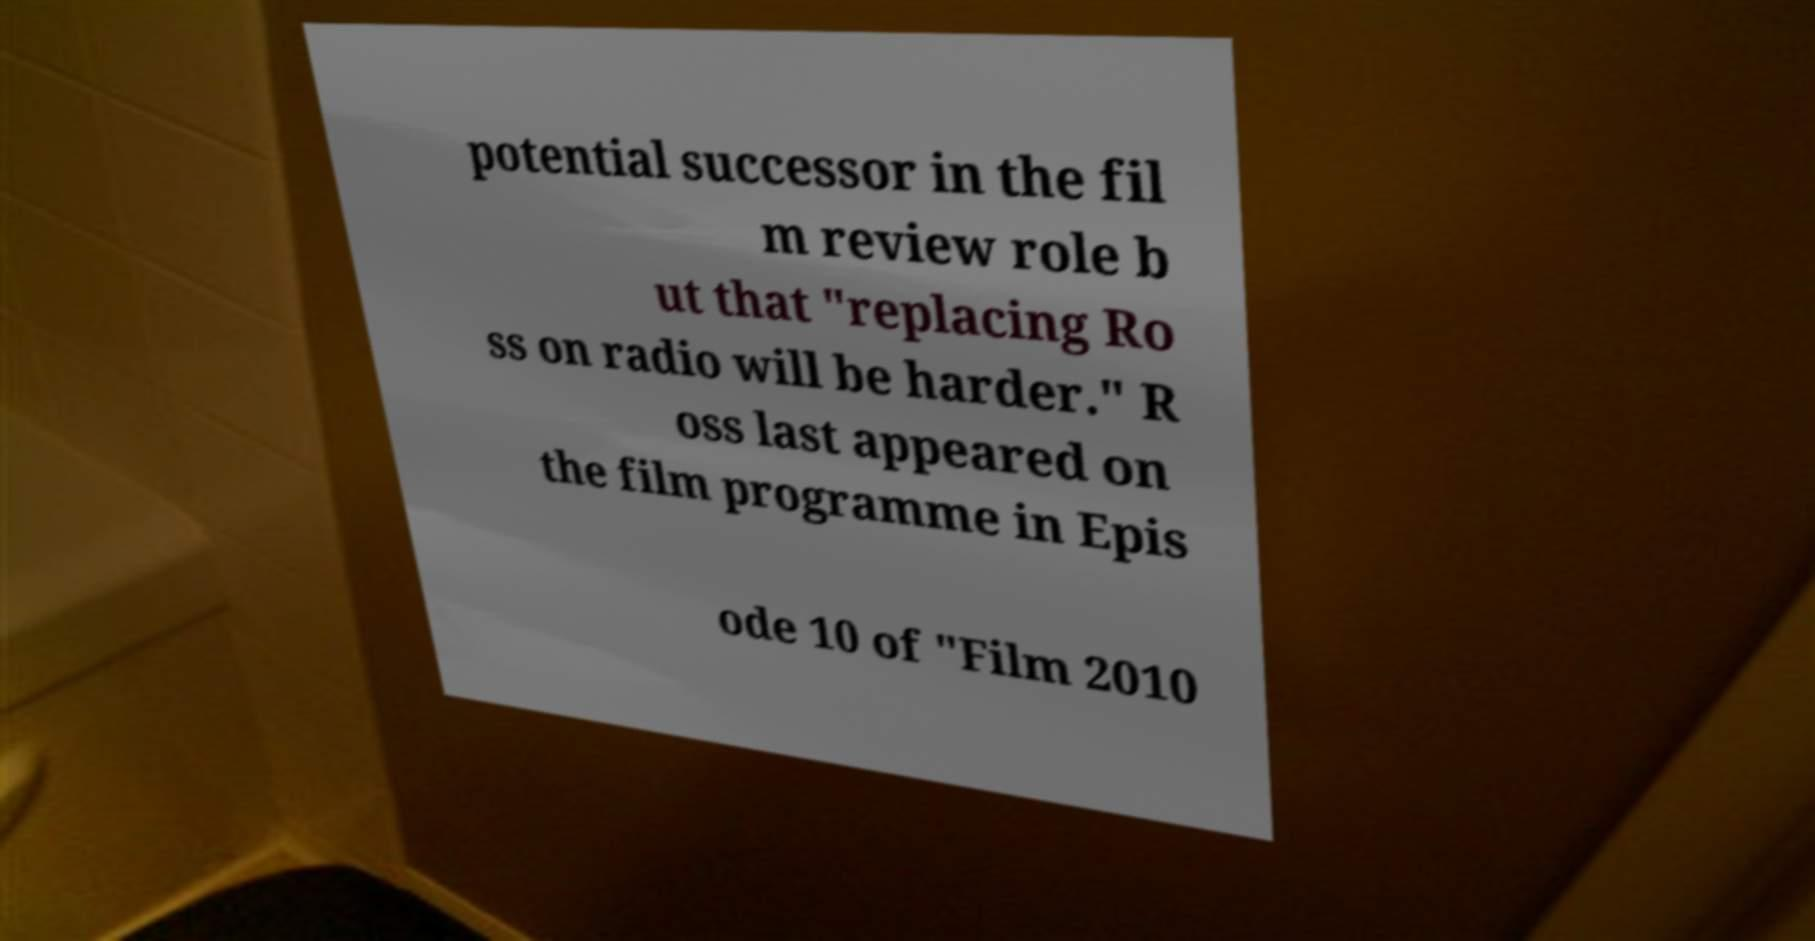What messages or text are displayed in this image? I need them in a readable, typed format. potential successor in the fil m review role b ut that "replacing Ro ss on radio will be harder." R oss last appeared on the film programme in Epis ode 10 of "Film 2010 